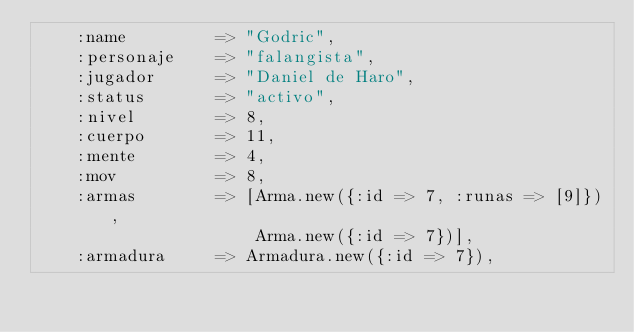Convert code to text. <code><loc_0><loc_0><loc_500><loc_500><_Ruby_>    :name         => "Godric",
    :personaje    => "falangista",
    :jugador      => "Daniel de Haro",
    :status       => "activo",
    :nivel        => 8,
    :cuerpo       => 11,
    :mente        => 4,
    :mov          => 8,
    :armas        => [Arma.new({:id => 7, :runas => [9]}), 
                      Arma.new({:id => 7})],
    :armadura     => Armadura.new({:id => 7}),</code> 